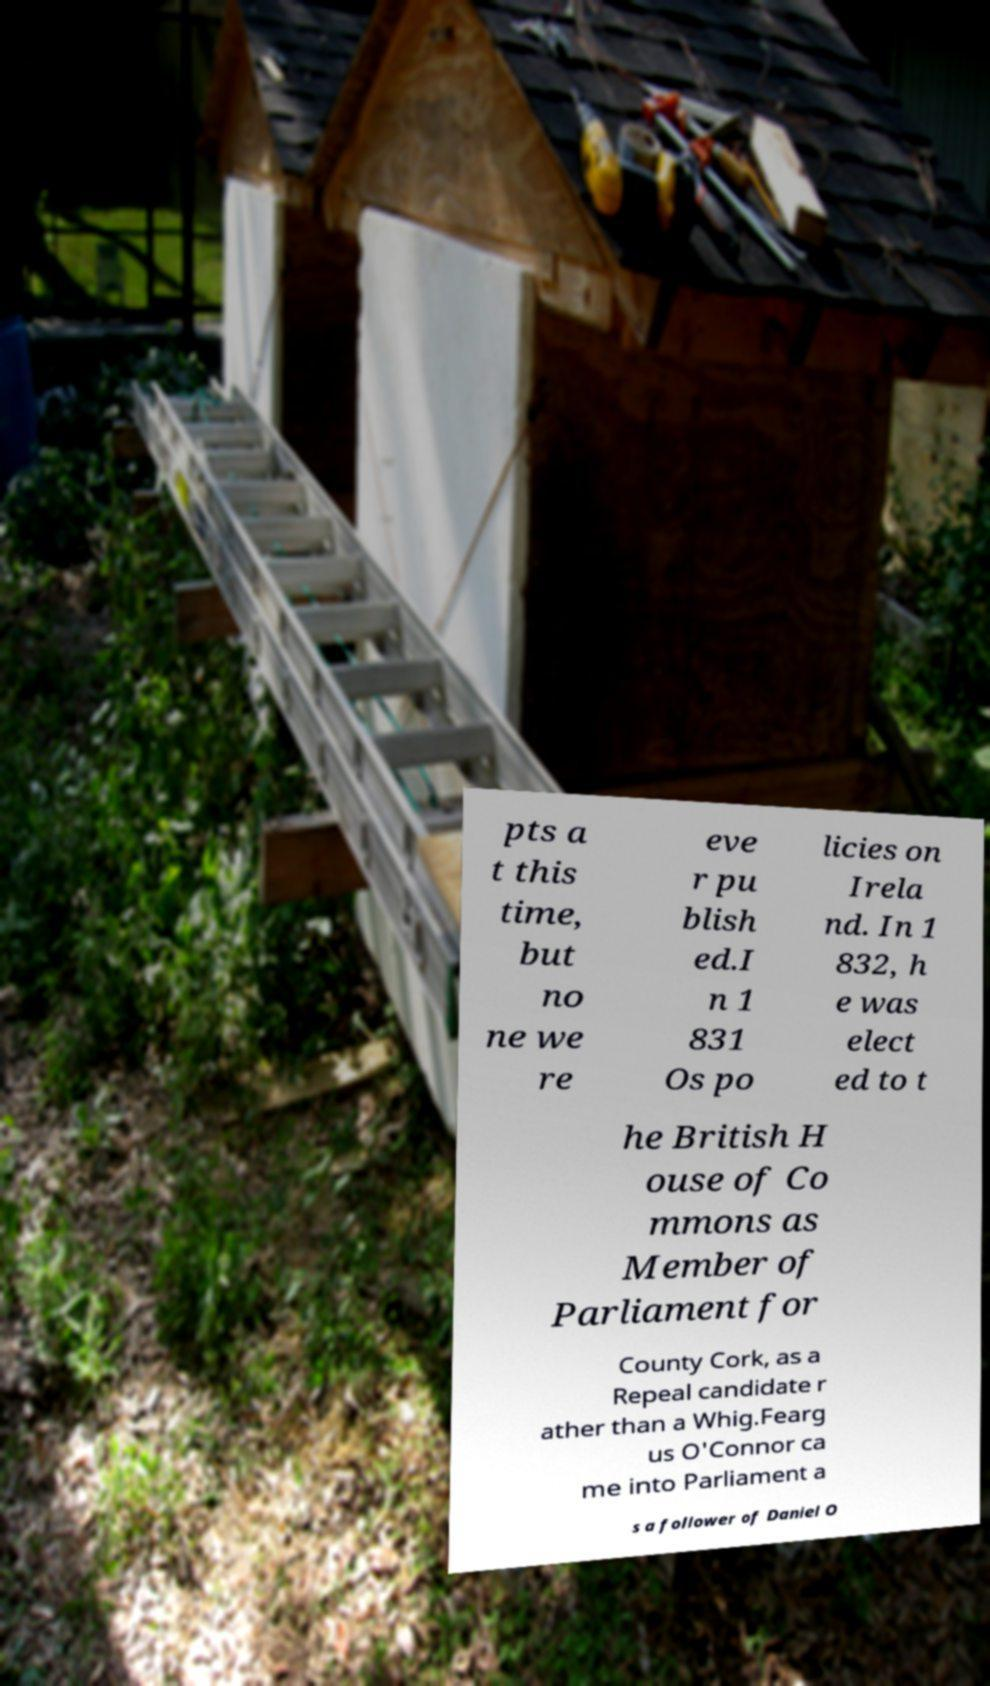Could you extract and type out the text from this image? pts a t this time, but no ne we re eve r pu blish ed.I n 1 831 Os po licies on Irela nd. In 1 832, h e was elect ed to t he British H ouse of Co mmons as Member of Parliament for County Cork, as a Repeal candidate r ather than a Whig.Fearg us O'Connor ca me into Parliament a s a follower of Daniel O 